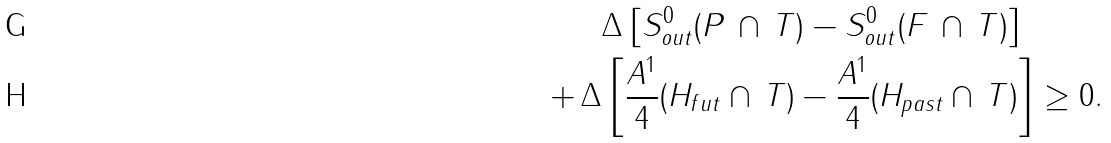<formula> <loc_0><loc_0><loc_500><loc_500>& \Delta \left [ S _ { o u t } ^ { 0 } ( P \, \cap \, T ) - S _ { o u t } ^ { 0 } ( F \, \cap \, T ) \right ] \\ + \, \Delta & \left [ \frac { A ^ { 1 } } { 4 } ( H _ { f u t } \cap \, T ) - \frac { A ^ { 1 } } { 4 } ( H _ { p a s t } \cap \, T ) \right ] \geq 0 .</formula> 